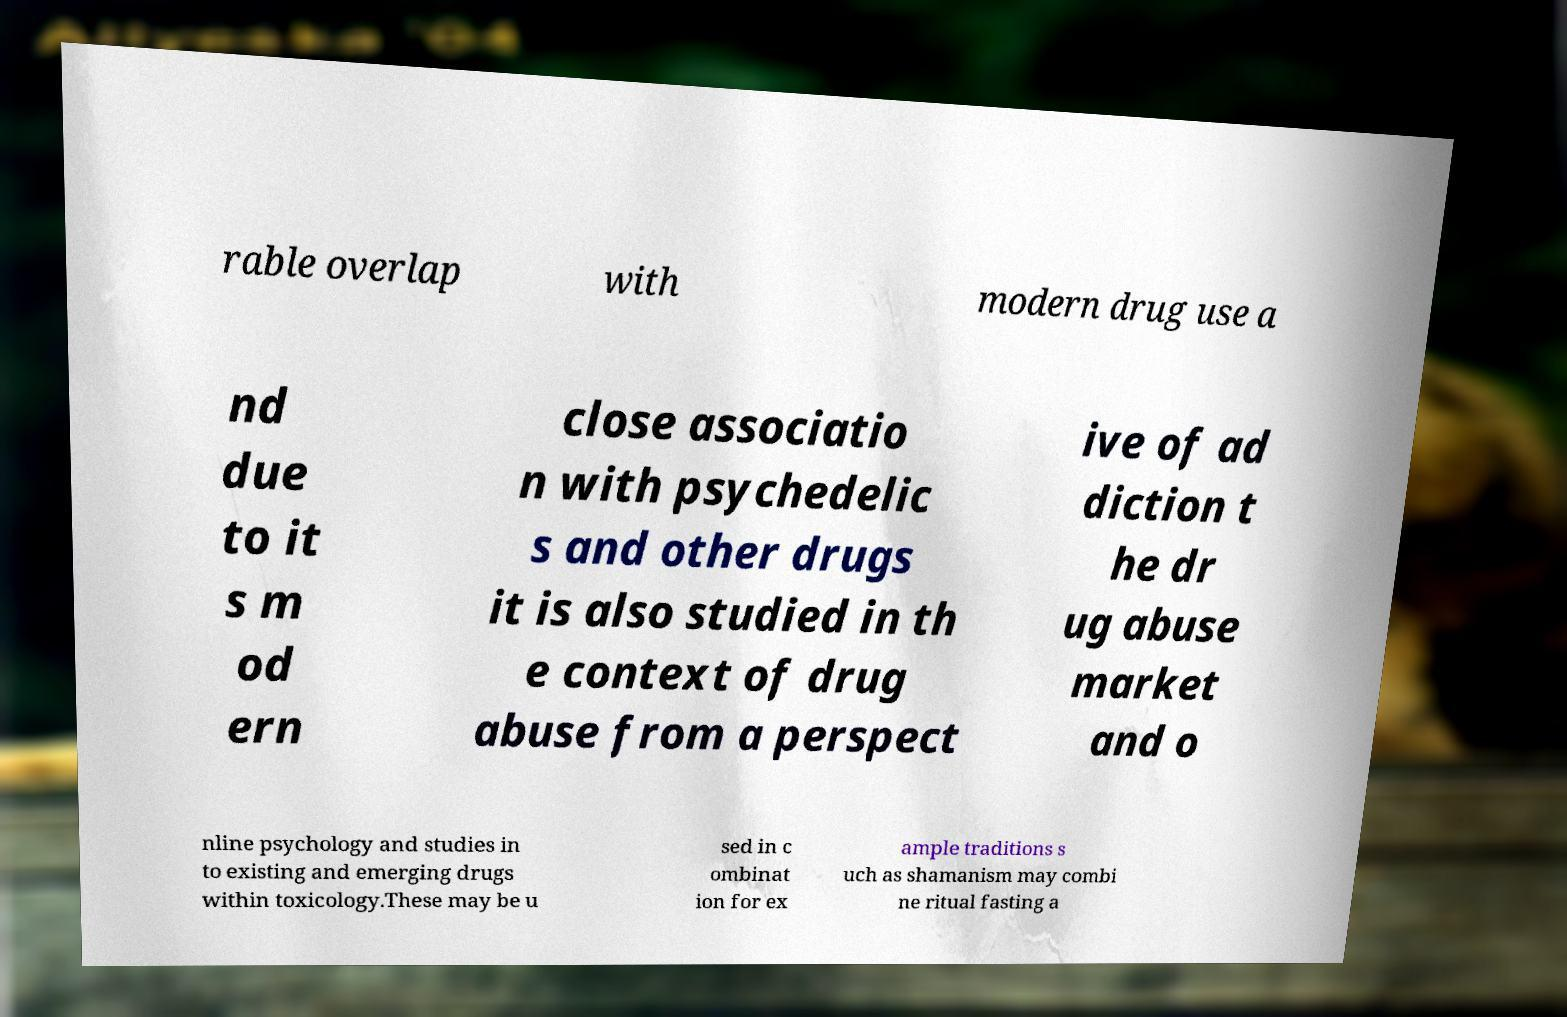For documentation purposes, I need the text within this image transcribed. Could you provide that? rable overlap with modern drug use a nd due to it s m od ern close associatio n with psychedelic s and other drugs it is also studied in th e context of drug abuse from a perspect ive of ad diction t he dr ug abuse market and o nline psychology and studies in to existing and emerging drugs within toxicology.These may be u sed in c ombinat ion for ex ample traditions s uch as shamanism may combi ne ritual fasting a 